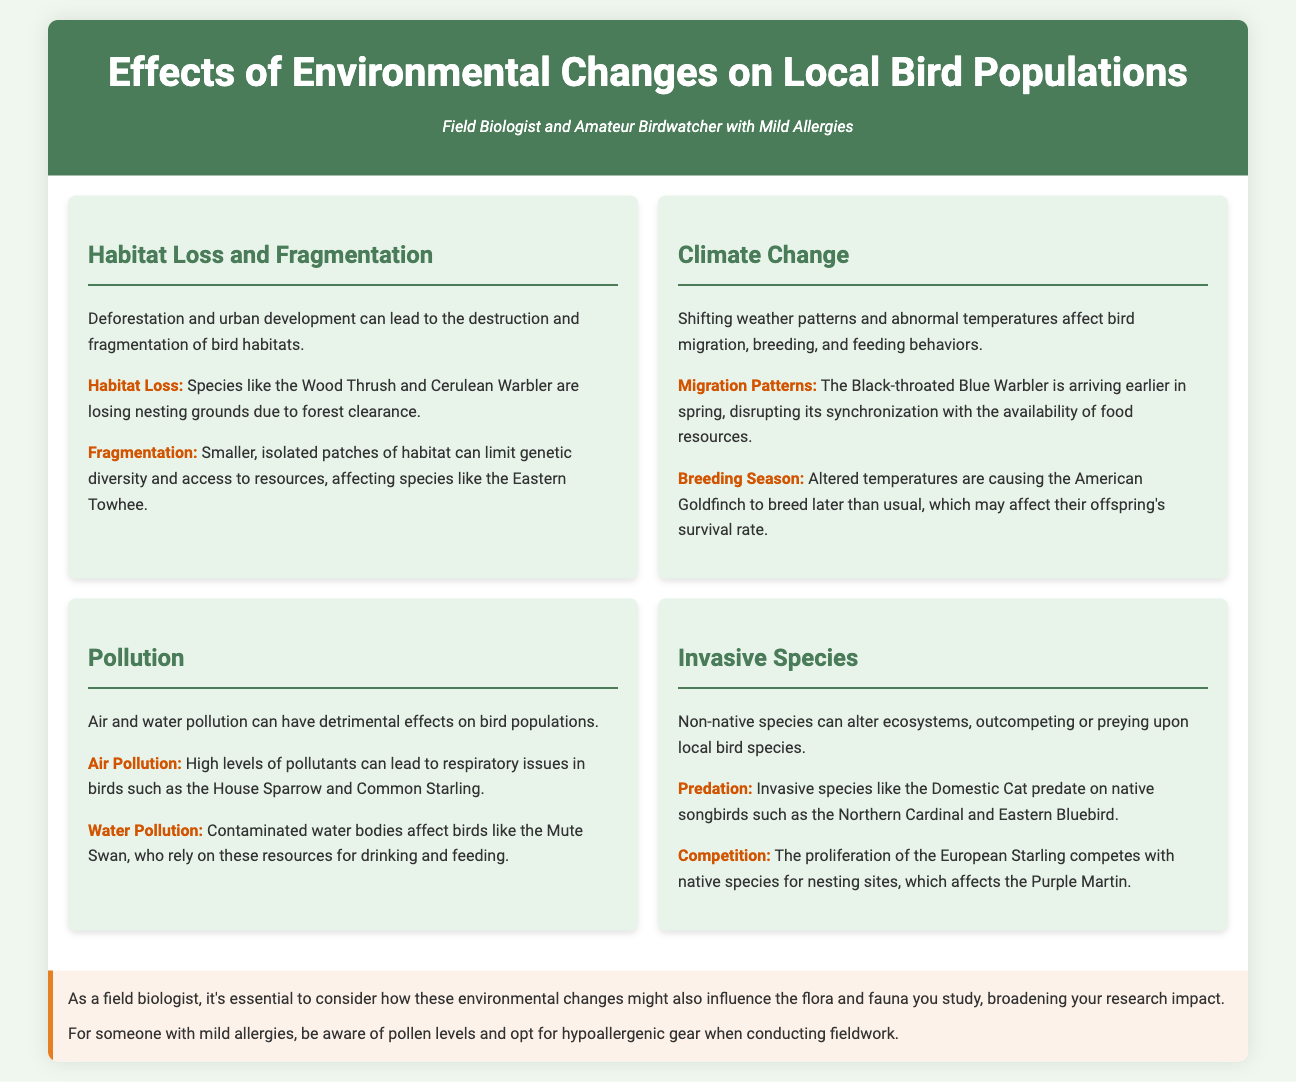What species are losing nesting grounds due to habitat loss? The species specifically mentioned in the document that are losing nesting grounds due to habitat loss are the Wood Thrush and Cerulean Warbler.
Answer: Wood Thrush and Cerulean Warbler What effect does climate change have on the Black-throated Blue Warbler? The document states that climate change is causing the Black-throated Blue Warbler to arrive earlier in spring, disrupting its synchronization with food resources.
Answer: Arriving earlier Which type of pollution affects the Mute Swan? The document specifies that water pollution affects the Mute Swan, as they rely on clean water for drinking and feeding.
Answer: Water pollution What invasive species predate on native songbirds? The document identifies the Domestic Cat as an invasive species that preys upon native songbirds such as the Northern Cardinal and Eastern Bluebird.
Answer: Domestic Cat How does habitat fragmentation affect the Eastern Towhee? According to the document, habitat fragmentation limits genetic diversity and access to resources for the Eastern Towhee.
Answer: Limits genetic diversity Which bird species is noted to breed later due to climate change? The American Goldfinch is mentioned in the document as breeding later than usual due to altered temperatures.
Answer: American Goldfinch What is one impact of air pollution on birds? The document states that high levels of air pollution can lead to respiratory issues in birds, specifically mentioning the House Sparrow and Common Starling.
Answer: Respiratory issues How do invasive species compete with purple martins? The document explains that the European Starling competes with native species for nesting sites, affecting the Purple Martin.
Answer: Competing for nesting sites 